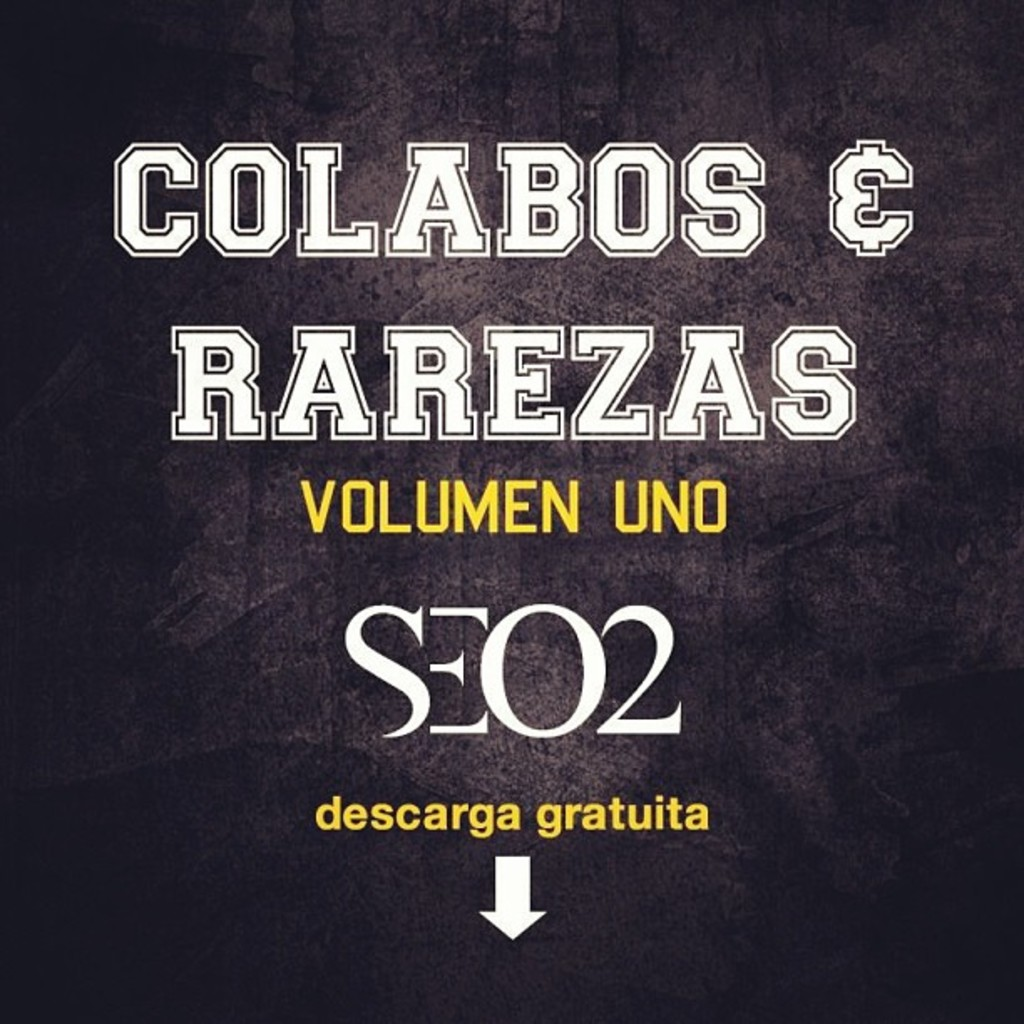Can you explain the choice of colors used in this album cover? The album cover uses a monochrome background with vibrant text highlights in yellow. This color choice creates a bold contrast, making the text stand out effectively. Yellow often conveys energy and attention-grabbing properties, which is apt for an album cover as it draws potential listeners' eyes. Meanwhile, the black background provides a powerful backdrop, suggesting depth and perhaps mirroring the genre or mood of the music. 